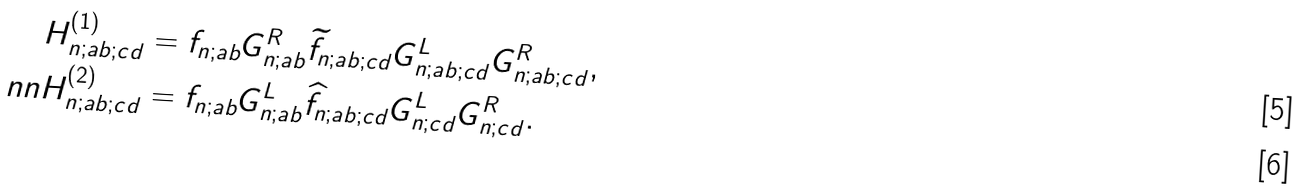Convert formula to latex. <formula><loc_0><loc_0><loc_500><loc_500>H _ { n ; a b ; c d } ^ { ( 1 ) } & = f _ { n ; a b } G _ { n ; a b } ^ { R } \widetilde { f } _ { n ; a b ; c d } G _ { n ; a b ; c d } ^ { L } G _ { n ; a b ; c d } ^ { R } , \\ \ n n H _ { n ; a b ; c d } ^ { ( 2 ) } & = f _ { n ; a b } G _ { n ; a b } ^ { L } \widehat { f } _ { n ; a b ; c d } G _ { n ; c d } ^ { L } G _ { n ; c d } ^ { R } .</formula> 